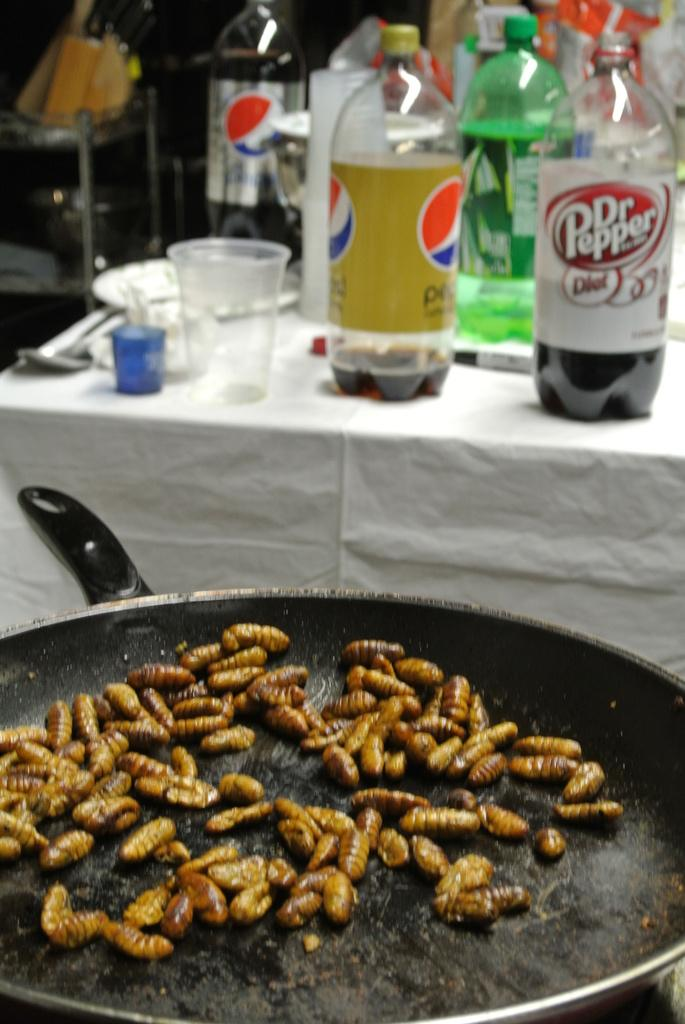<image>
Give a short and clear explanation of the subsequent image. Several large soda bottles are visible on a far table, including Pepsi and Dr. Pepper. 